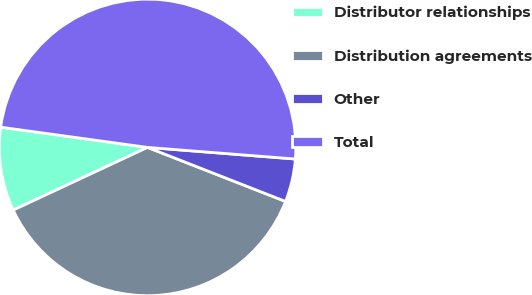<chart> <loc_0><loc_0><loc_500><loc_500><pie_chart><fcel>Distributor relationships<fcel>Distribution agreements<fcel>Other<fcel>Total<nl><fcel>9.13%<fcel>37.11%<fcel>4.69%<fcel>49.07%<nl></chart> 